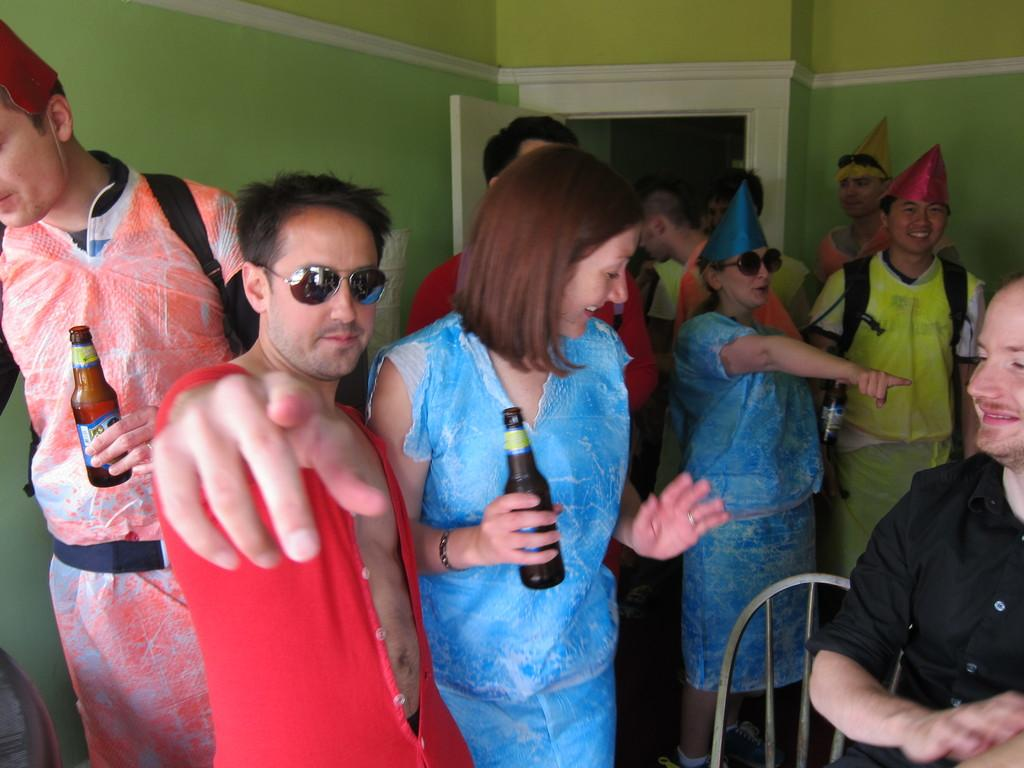How many people are in the image? There is a group of people in the image. What are some of the people wearing? Some of the people are wearing hats and spectacles. What are three persons holding in the image? Three persons are holding bottles. What furniture item is present in the image? There is a chair in the image. What architectural features can be seen in the background of the image? There is a wall and a door in the background of the image. What type of coastline can be seen in the image? There is no coastline visible in the image. How many cherries are being eaten by the people in the image? There are no cherries present in the image. 